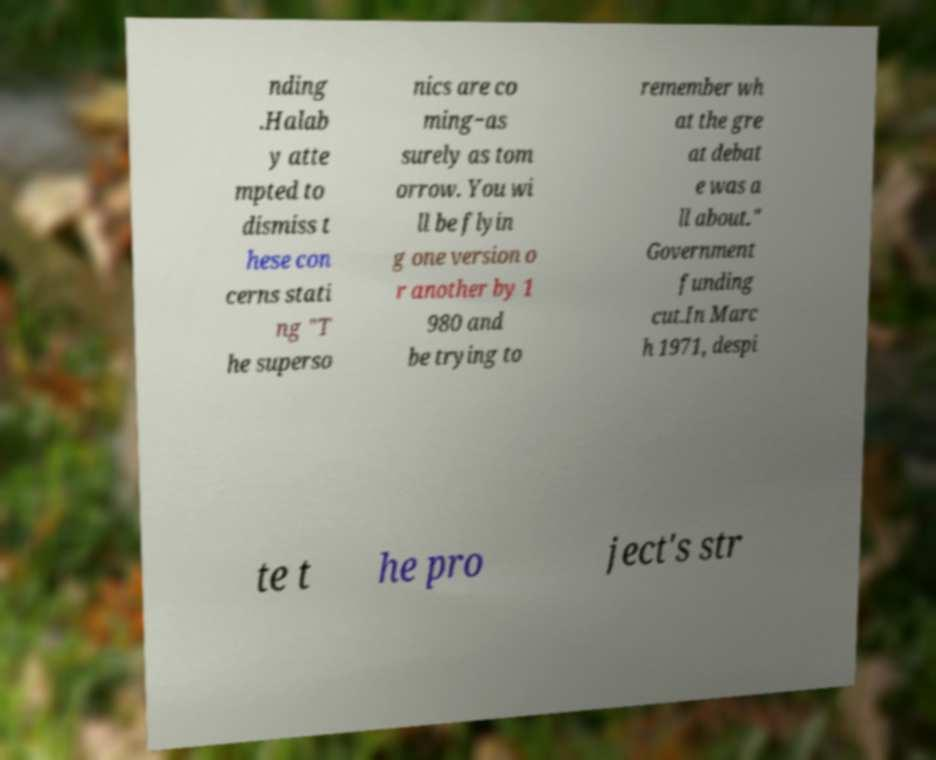For documentation purposes, I need the text within this image transcribed. Could you provide that? nding .Halab y atte mpted to dismiss t hese con cerns stati ng "T he superso nics are co ming−as surely as tom orrow. You wi ll be flyin g one version o r another by 1 980 and be trying to remember wh at the gre at debat e was a ll about." Government funding cut.In Marc h 1971, despi te t he pro ject's str 